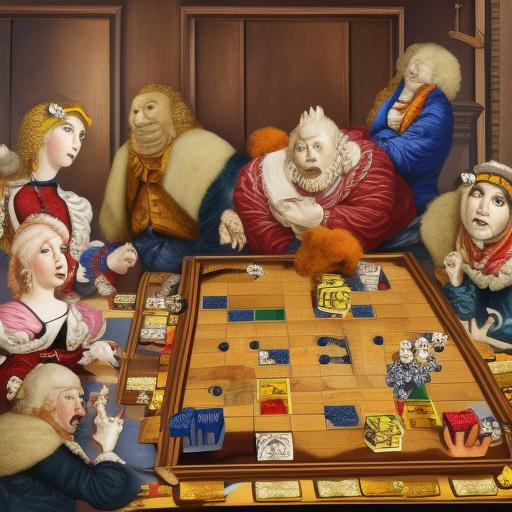Are people playing chess in the painting? Absolutely! The painting captures a lively scene where several individuals are engrossed in a game of chess. Each character seems to be intensely focused on the game, suggesting a moment of strategic contemplation and friendly competition. 